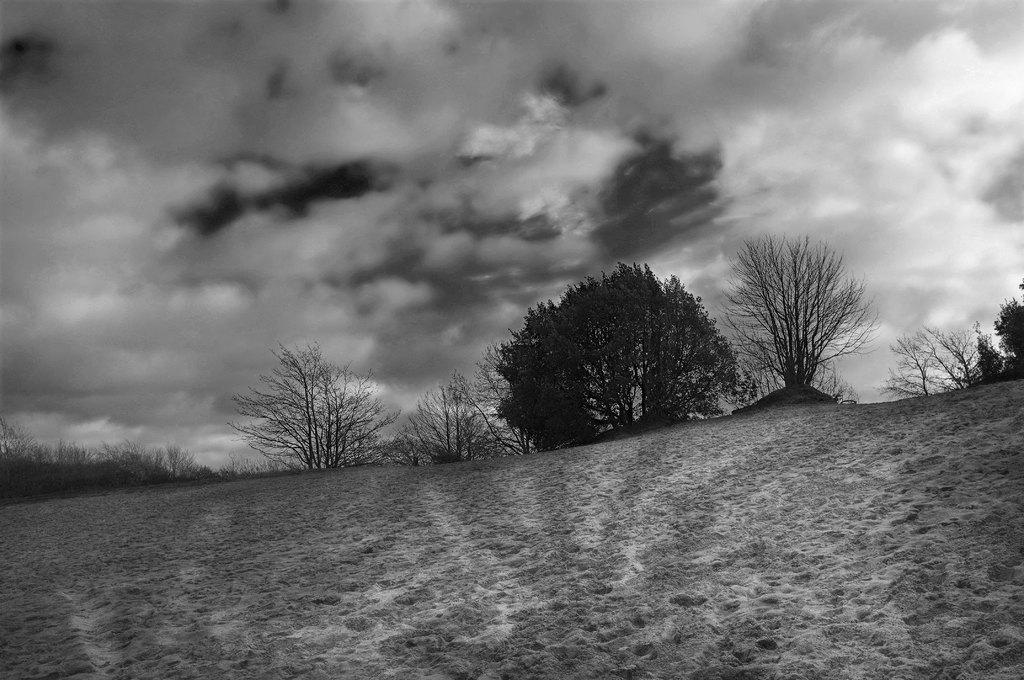Describe this image in one or two sentences. This is a black and white picture, in the back there are trees on the land and above its sky with clouds. 